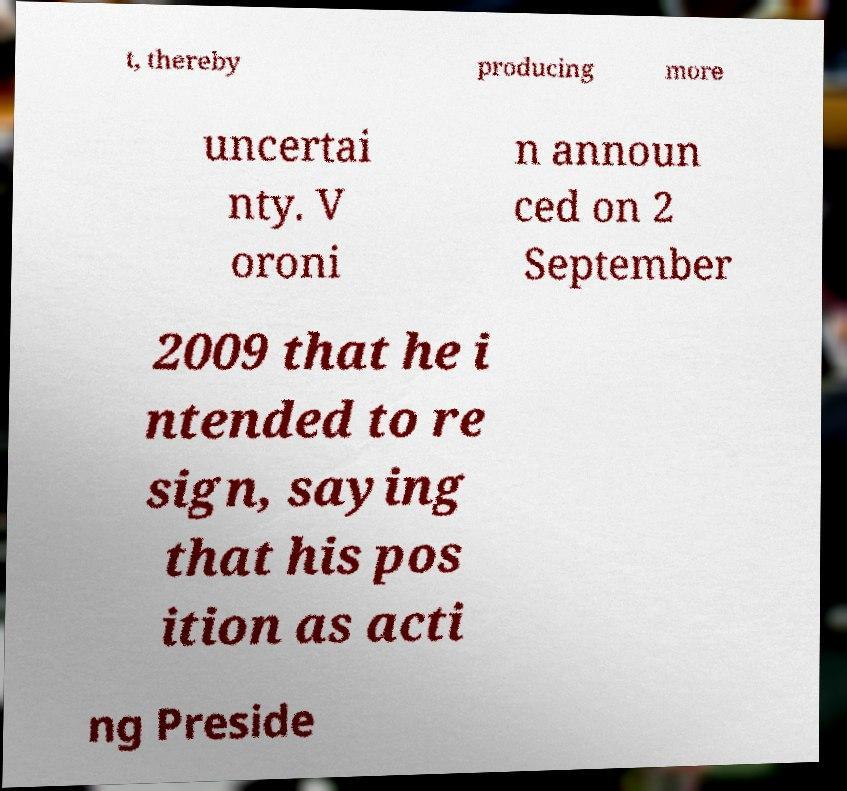Could you assist in decoding the text presented in this image and type it out clearly? t, thereby producing more uncertai nty. V oroni n announ ced on 2 September 2009 that he i ntended to re sign, saying that his pos ition as acti ng Preside 